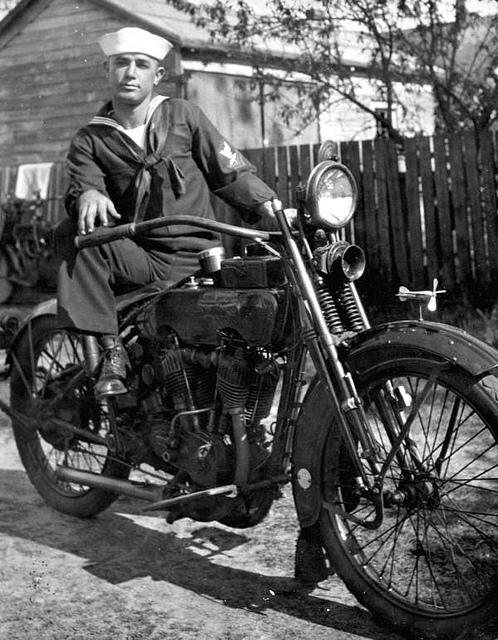What time period do you think this is from?
Be succinct. 1940's. What is the man sitting on?
Short answer required. Motorcycle. What uniform is the man wearing?
Write a very short answer. Sailor. 